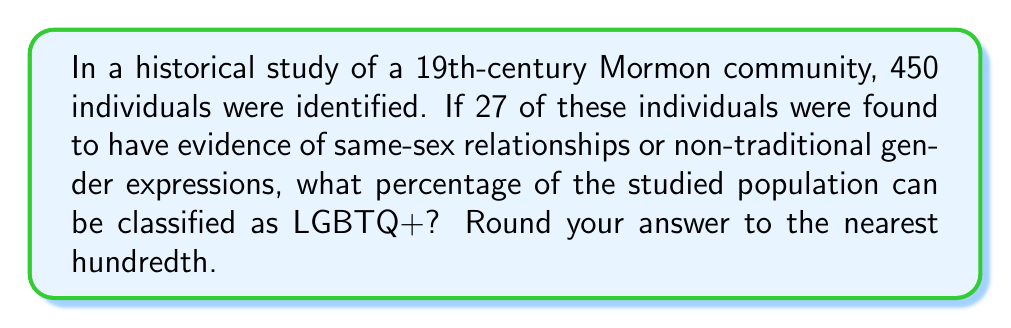Give your solution to this math problem. To calculate the percentage of LGBTQ+ individuals in the historical Mormon population:

1. Identify the total population: $n = 450$
2. Identify the number of LGBTQ+ individuals: $x = 27$
3. Use the formula for percentage: $\text{Percentage} = \frac{\text{Part}}{\text{Whole}} \times 100\%$
4. Plug in the values:
   $$\text{Percentage} = \frac{27}{450} \times 100\%$$
5. Simplify the fraction:
   $$\text{Percentage} = 0.06 \times 100\%$$
6. Calculate:
   $$\text{Percentage} = 6\%$$
7. Round to the nearest hundredth (already in that form).

Therefore, 6.00% of the studied historical Mormon population can be classified as LGBTQ+.
Answer: 6.00% 